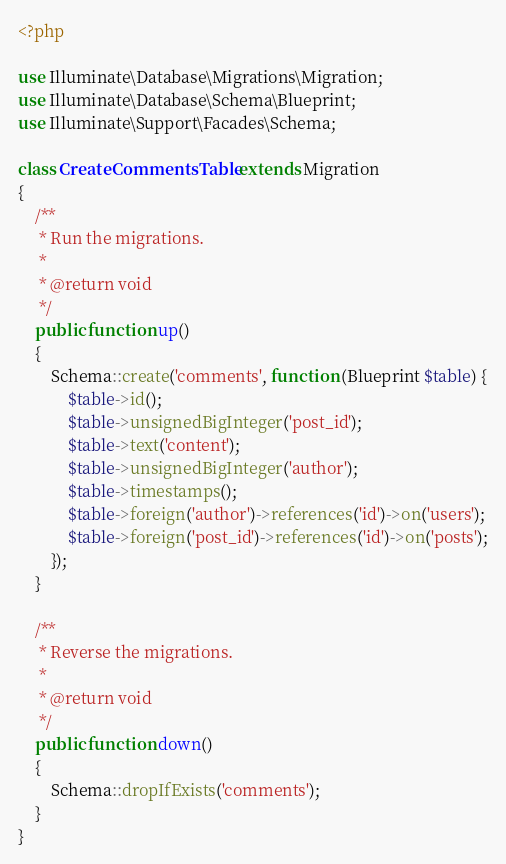<code> <loc_0><loc_0><loc_500><loc_500><_PHP_><?php

use Illuminate\Database\Migrations\Migration;
use Illuminate\Database\Schema\Blueprint;
use Illuminate\Support\Facades\Schema;

class CreateCommentsTable extends Migration
{
    /**
     * Run the migrations.
     *
     * @return void
     */
    public function up()
    {
        Schema::create('comments', function (Blueprint $table) {
            $table->id();
            $table->unsignedBigInteger('post_id');
            $table->text('content');
            $table->unsignedBigInteger('author');
            $table->timestamps();
            $table->foreign('author')->references('id')->on('users');
            $table->foreign('post_id')->references('id')->on('posts');
        });
    }

    /**
     * Reverse the migrations.
     *
     * @return void
     */
    public function down()
    {
        Schema::dropIfExists('comments');
    }
}
</code> 